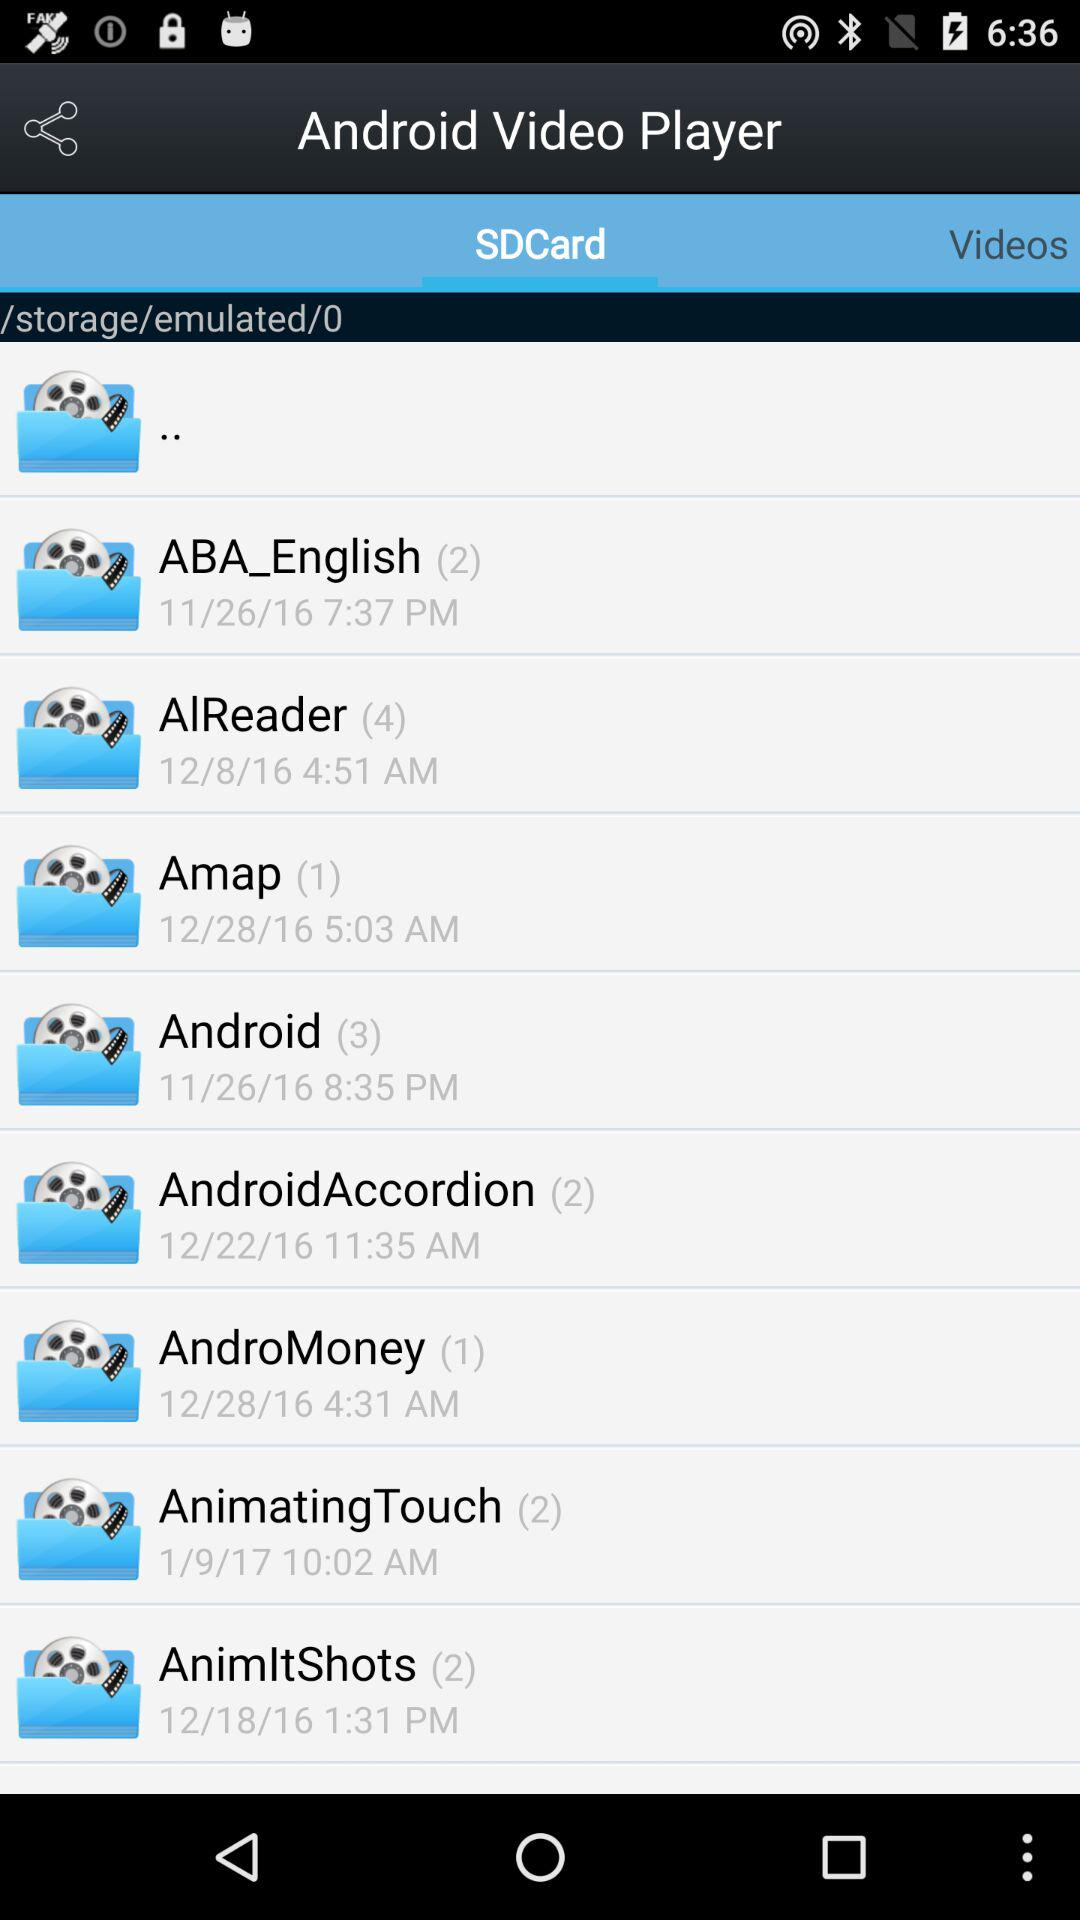At 5:03 AM, which folder was created? The folder created at 5:03 AM was "Amap". 